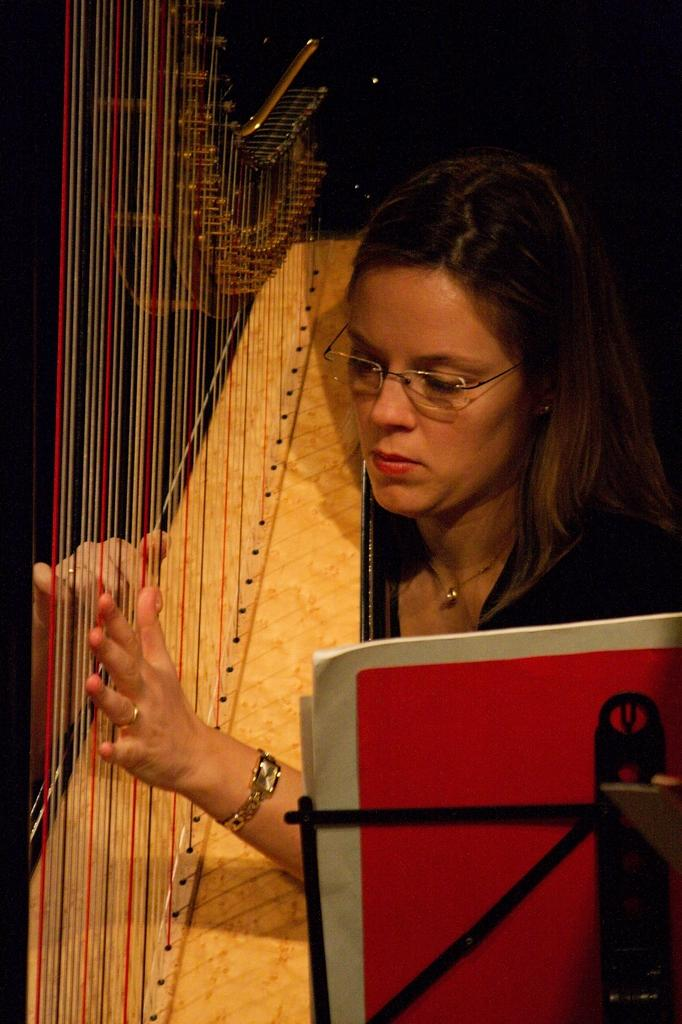Who is the main subject in the image? There is a woman in the image. What is the woman holding in the image? The woman is holding a harp. What can be seen on the right side of the image? There is a stand on the right side of the image. What color and pattern are the objects on the stand? The objects on the stand are red and white. What is the color of the background in the image? The background of the image is black. What type of cheese is being offered by the crook in the image? There is no crook or cheese present in the image. What month is depicted in the image? The image does not depict a specific month; it is a woman holding a harp with a black background. 